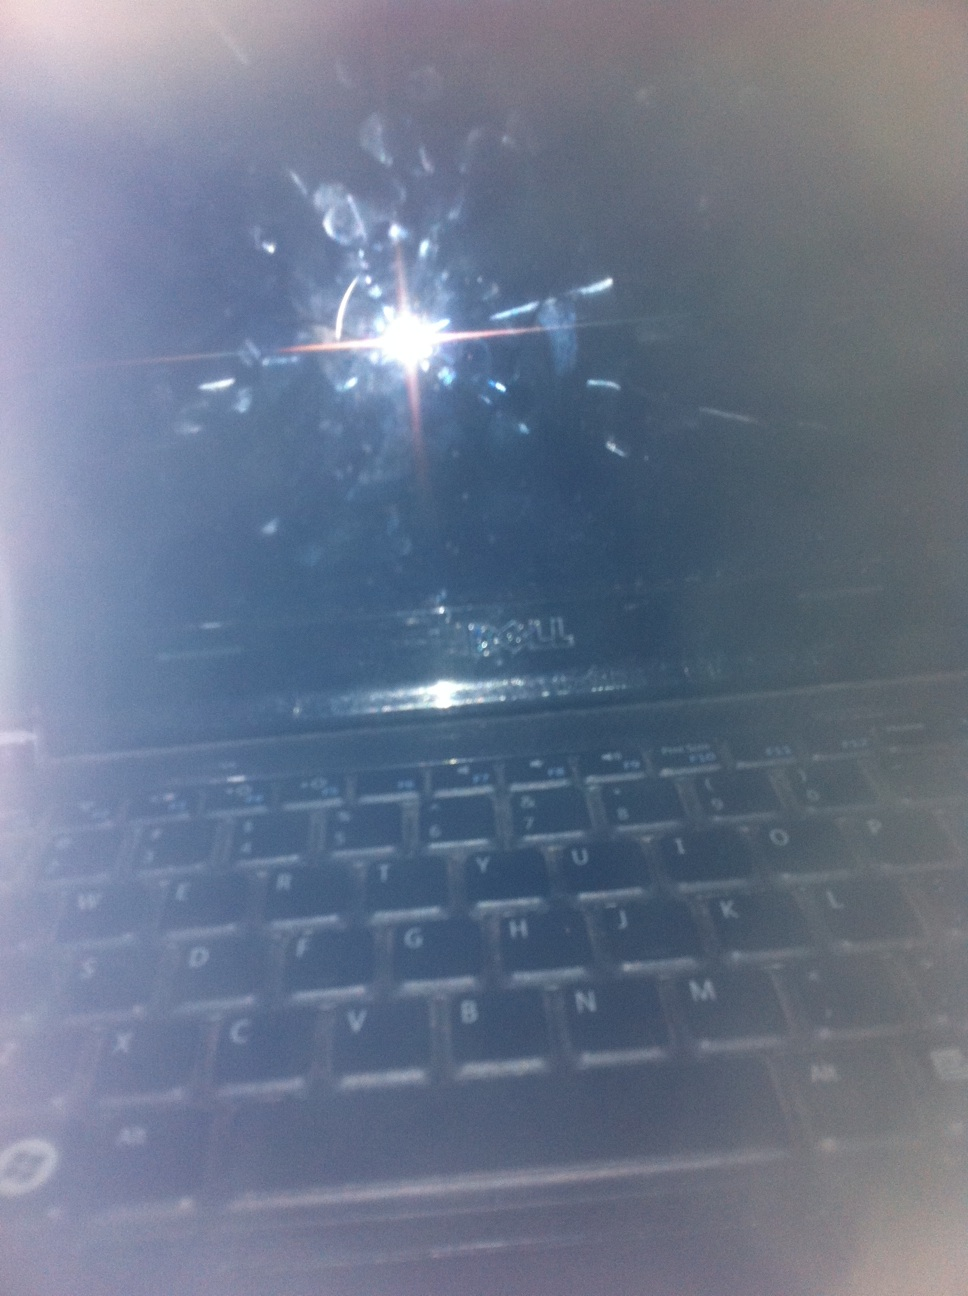Describe this image in abstract and imaginative terms. The image resembles a portal to a different dimension, cloaked in shadows and ethereal light. The streaks and smudges on the screen could be interpreted as cosmic dust swirling around the portal's entrance while a mysterious entity from beyond peers through, casting a single beam of light that pierces the dark veil. 